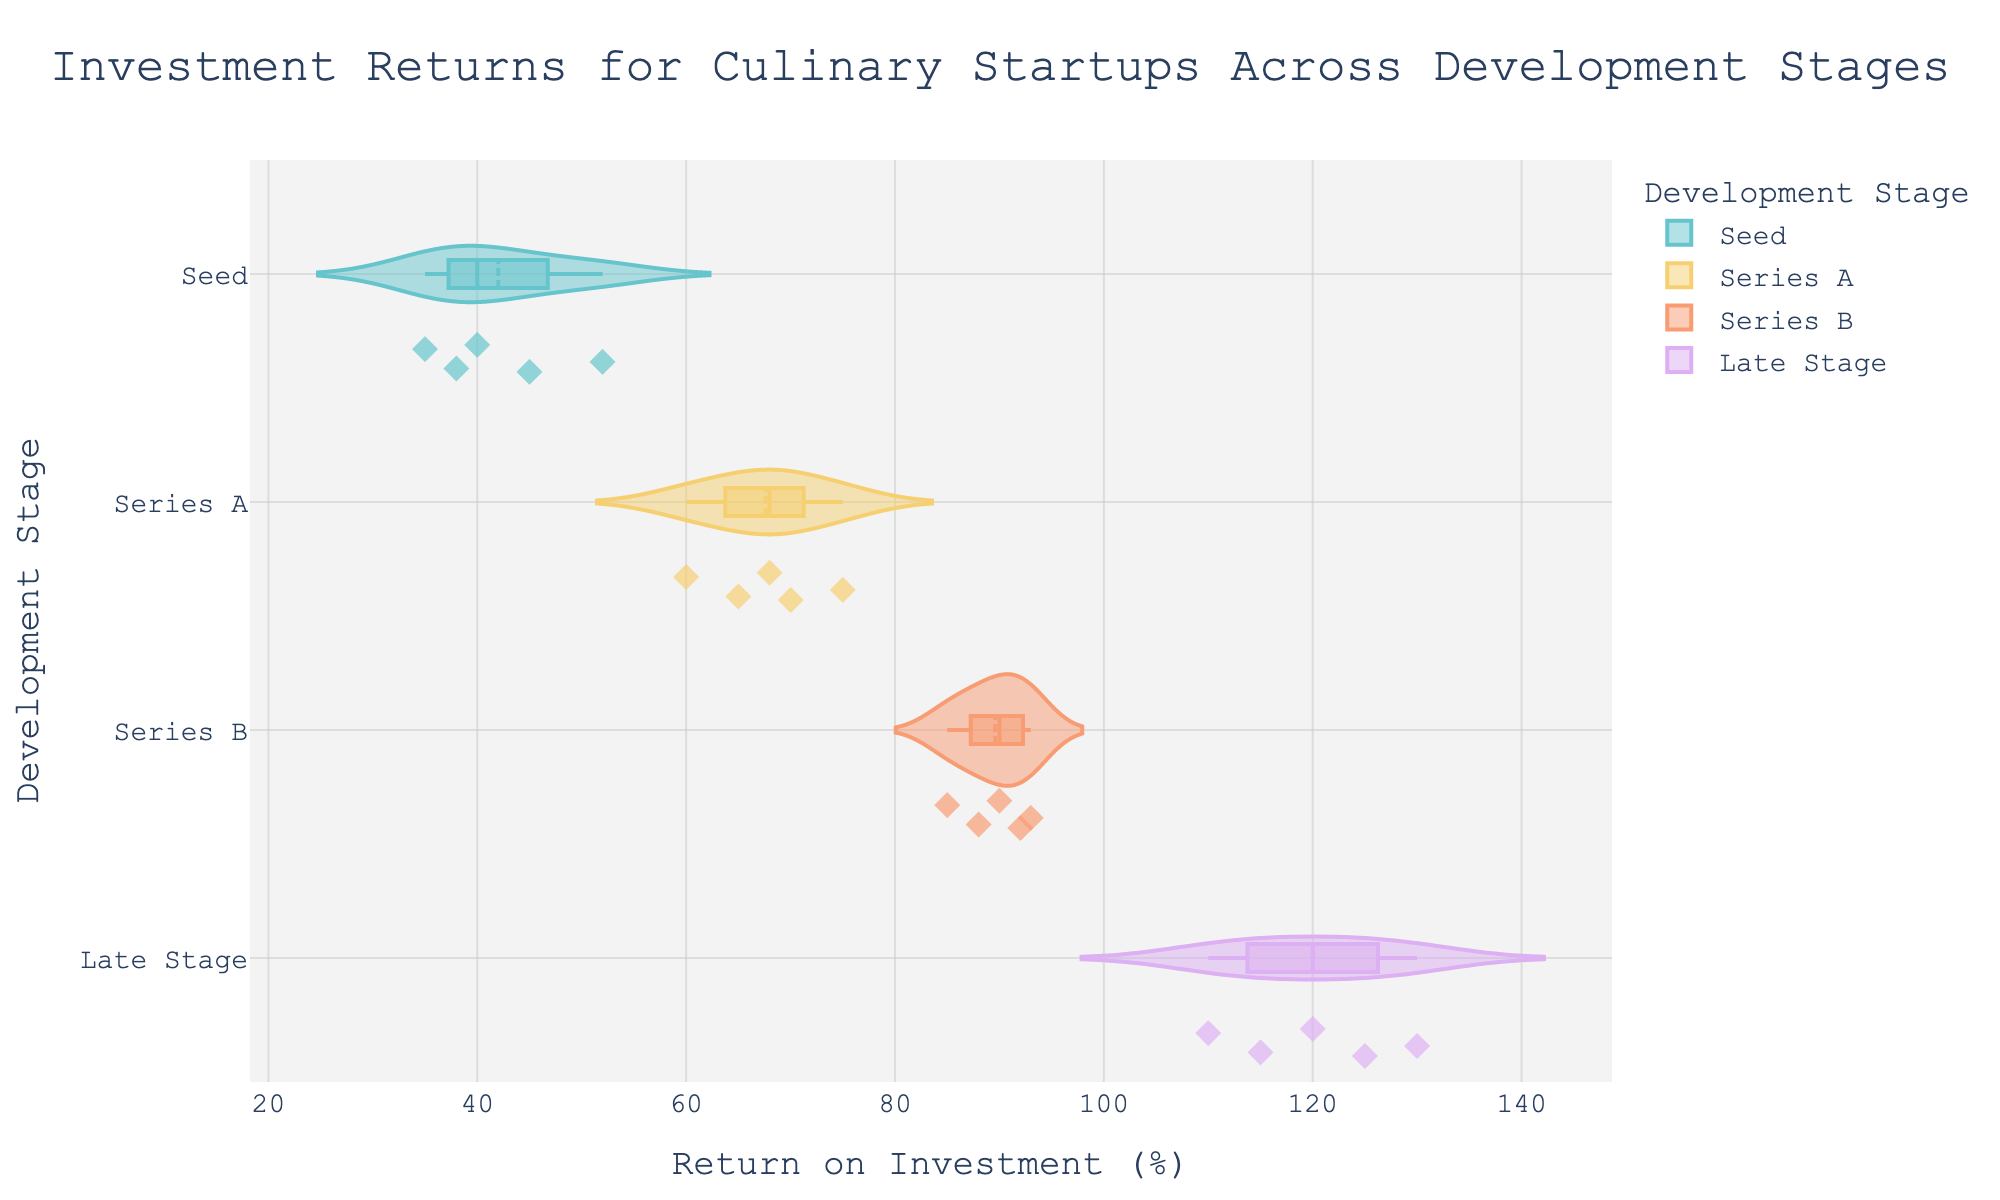What's the title of the figure? The title is located at the top center of the figure and clearly states the content.
Answer: "Investment Returns for Culinary Startups Across Development Stages" How many data points are there in the 'Series B' stage? The 'Series B' stage violin plot shows all individual data points. By counting them, we see five data points.
Answer: 5 Which stage has the highest median investment return? Examining the box plots within each violin plot, the horizontal line inside each box indicates the median. The 'Late Stage' has the highest median.
Answer: Late Stage What is the typical range of investment returns for the 'Seed' stage? The range can be determined by looking at the spread of the data points and the width of the violin plot. The 'Seed' stage shows a range roughly from 35% to 52%.
Answer: 35%-52% Compare the average investment return between 'Seed' and 'Series A' stages. To approximate the average return, one can use the median values as an indicator. The 'Series A' median is higher than the 'Seed' median.
Answer: Series A > Seed What is the interquartile range in the 'Late Stage'? The interquartile range (IQR) is the width of the box in the plot. For 'Late Stage', it's approximately between 110% and 130%, so 130 - 110 = 20.
Answer: 20% How do the distributions of returns compare between 'Series A' and 'Series B'? By comparing the shapes and spreads of the violin plots, 'Series A' has a tighter, more centralized distribution, while 'Series B' is slightly wider but centered.
Answer: Series A is tighter, Series B is wider Which stage shows the most variability in returns? The variability can be assessed by the width and extent of the violin plot. 'Seed' stage shows the most spread.
Answer: Seed Is there any stage where the mean and median are significantly different? The mean line shown in each plot indicates if it's significantly different from the median. No stage shows a dramatic difference.
Answer: No significant difference 